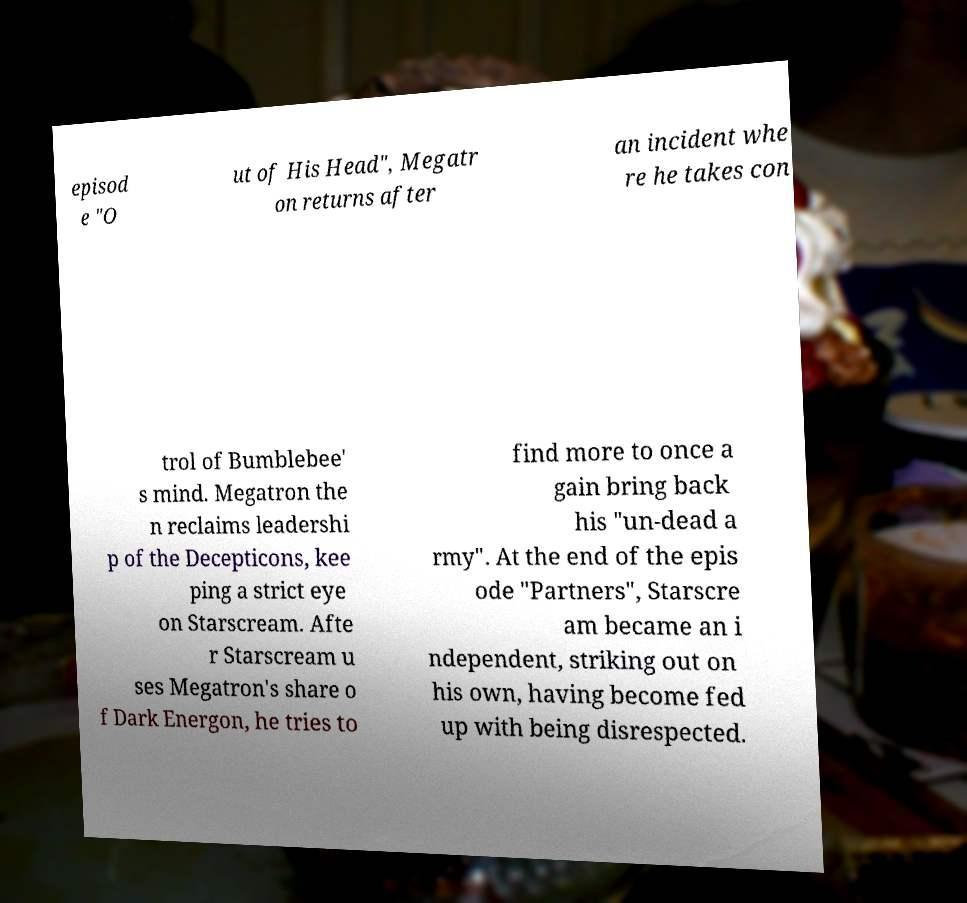I need the written content from this picture converted into text. Can you do that? episod e "O ut of His Head", Megatr on returns after an incident whe re he takes con trol of Bumblebee' s mind. Megatron the n reclaims leadershi p of the Decepticons, kee ping a strict eye on Starscream. Afte r Starscream u ses Megatron's share o f Dark Energon, he tries to find more to once a gain bring back his "un-dead a rmy". At the end of the epis ode "Partners", Starscre am became an i ndependent, striking out on his own, having become fed up with being disrespected. 